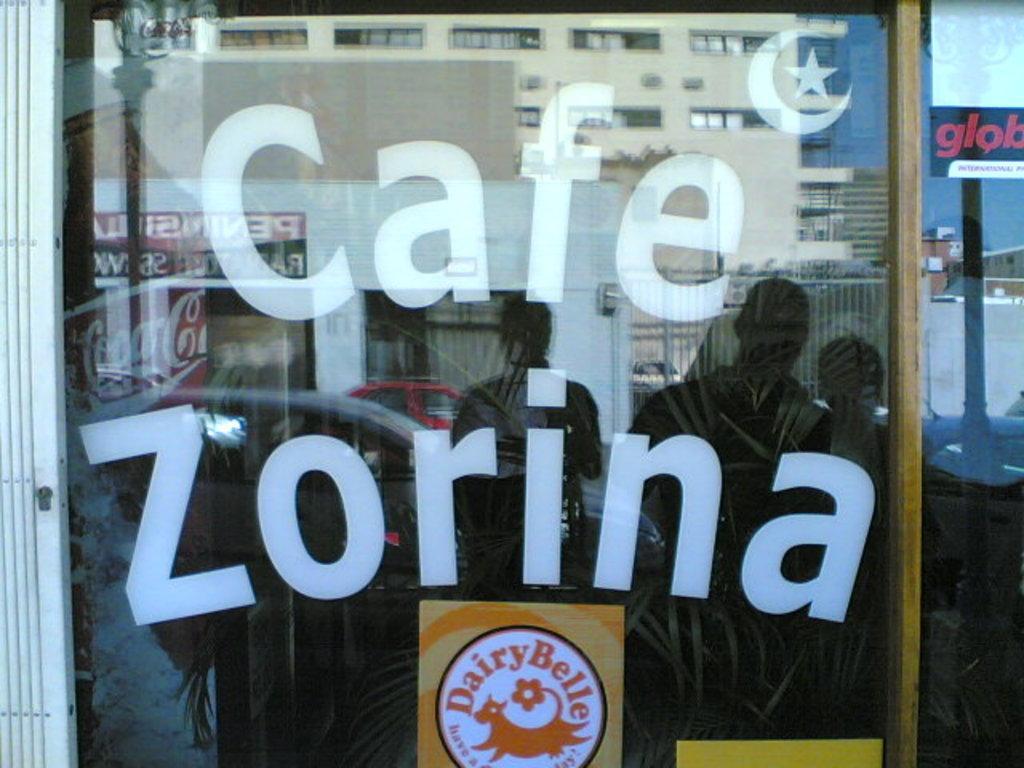In one or two sentences, can you explain what this image depicts? In this picture there is a coffee store in the center of the image, on which there are posters and there are people, cars, and buildings, which are reflecting in the mirror. 